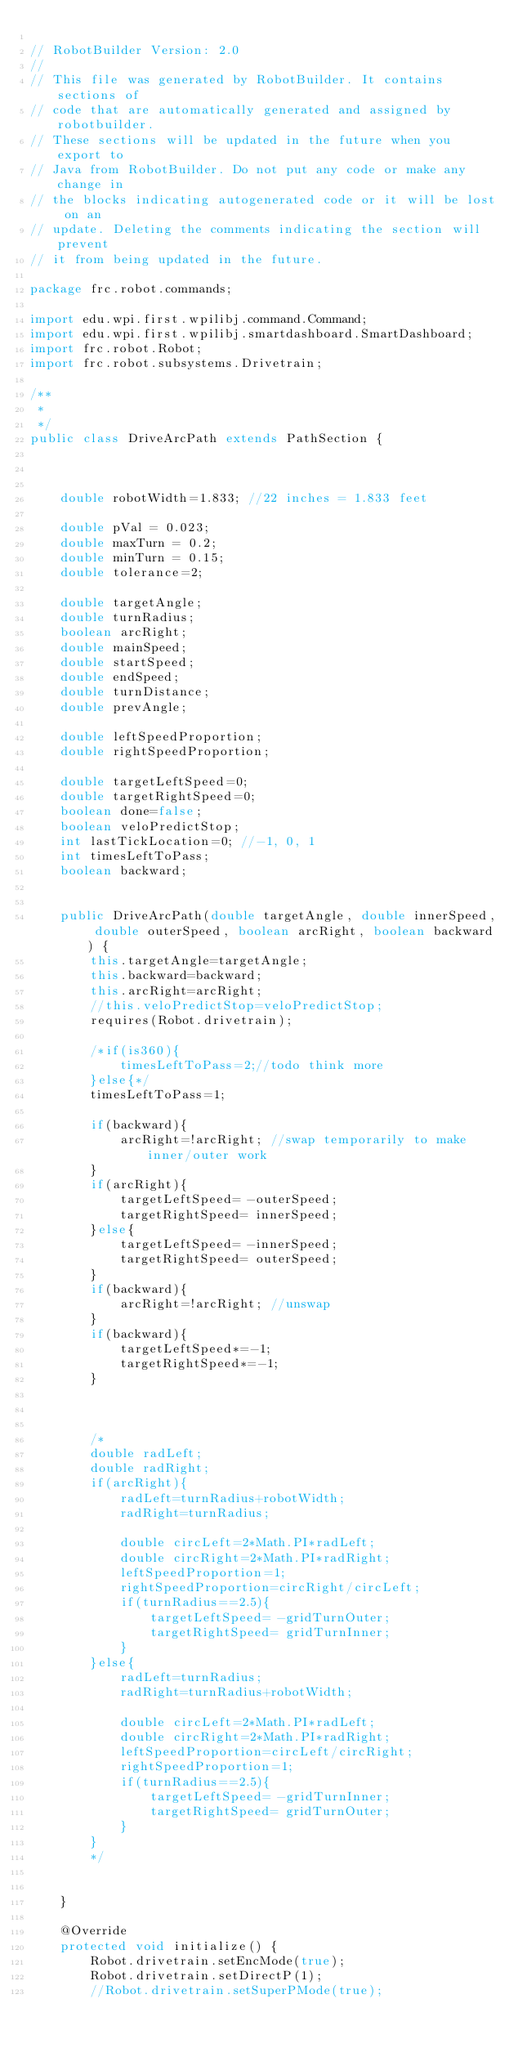<code> <loc_0><loc_0><loc_500><loc_500><_Java_>
// RobotBuilder Version: 2.0
//
// This file was generated by RobotBuilder. It contains sections of
// code that are automatically generated and assigned by robotbuilder.
// These sections will be updated in the future when you export to
// Java from RobotBuilder. Do not put any code or make any change in
// the blocks indicating autogenerated code or it will be lost on an
// update. Deleting the comments indicating the section will prevent
// it from being updated in the future.

package frc.robot.commands;

import edu.wpi.first.wpilibj.command.Command;
import edu.wpi.first.wpilibj.smartdashboard.SmartDashboard;
import frc.robot.Robot;
import frc.robot.subsystems.Drivetrain;

/**
 *
 */
public class DriveArcPath extends PathSection {

   
    
    double robotWidth=1.833; //22 inches = 1.833 feet
    
    double pVal = 0.023;
    double maxTurn = 0.2;
    double minTurn = 0.15;
    double tolerance=2;

    double targetAngle;
    double turnRadius;
    boolean arcRight;
    double mainSpeed;
    double startSpeed;
    double endSpeed;
    double turnDistance;
    double prevAngle;

    double leftSpeedProportion;
    double rightSpeedProportion;

    double targetLeftSpeed=0;
    double targetRightSpeed=0;
    boolean done=false;
    boolean veloPredictStop;
    int lastTickLocation=0; //-1, 0, 1
    int timesLeftToPass;
    boolean backward;
    
    
    public DriveArcPath(double targetAngle, double innerSpeed, double outerSpeed, boolean arcRight, boolean backward) {
        this.targetAngle=targetAngle;
        this.backward=backward;
        this.arcRight=arcRight;
        //this.veloPredictStop=veloPredictStop;
        requires(Robot.drivetrain);

        /*if(is360){
            timesLeftToPass=2;//todo think more
        }else{*/
        timesLeftToPass=1;
        
        if(backward){
            arcRight=!arcRight; //swap temporarily to make inner/outer work
        }
        if(arcRight){
            targetLeftSpeed= -outerSpeed;
            targetRightSpeed= innerSpeed;
        }else{
            targetLeftSpeed= -innerSpeed;
            targetRightSpeed= outerSpeed;
        }
        if(backward){
            arcRight=!arcRight; //unswap
        }
        if(backward){
            targetLeftSpeed*=-1;
            targetRightSpeed*=-1;
        }


        
        /*
        double radLeft;
        double radRight;
        if(arcRight){
            radLeft=turnRadius+robotWidth;
            radRight=turnRadius;

            double circLeft=2*Math.PI*radLeft;
            double circRight=2*Math.PI*radRight;
            leftSpeedProportion=1;
            rightSpeedProportion=circRight/circLeft;
            if(turnRadius==2.5){
                targetLeftSpeed= -gridTurnOuter;
                targetRightSpeed= gridTurnInner;
            }
        }else{
            radLeft=turnRadius;
            radRight=turnRadius+robotWidth;

            double circLeft=2*Math.PI*radLeft;
            double circRight=2*Math.PI*radRight;
            leftSpeedProportion=circLeft/circRight;
            rightSpeedProportion=1;
            if(turnRadius==2.5){
                targetLeftSpeed= -gridTurnInner;
                targetRightSpeed= gridTurnOuter;
            }
        }
        */
        

    }

    @Override
    protected void initialize() {
        Robot.drivetrain.setEncMode(true);
        Robot.drivetrain.setDirectP(1);
        //Robot.drivetrain.setSuperPMode(true);</code> 